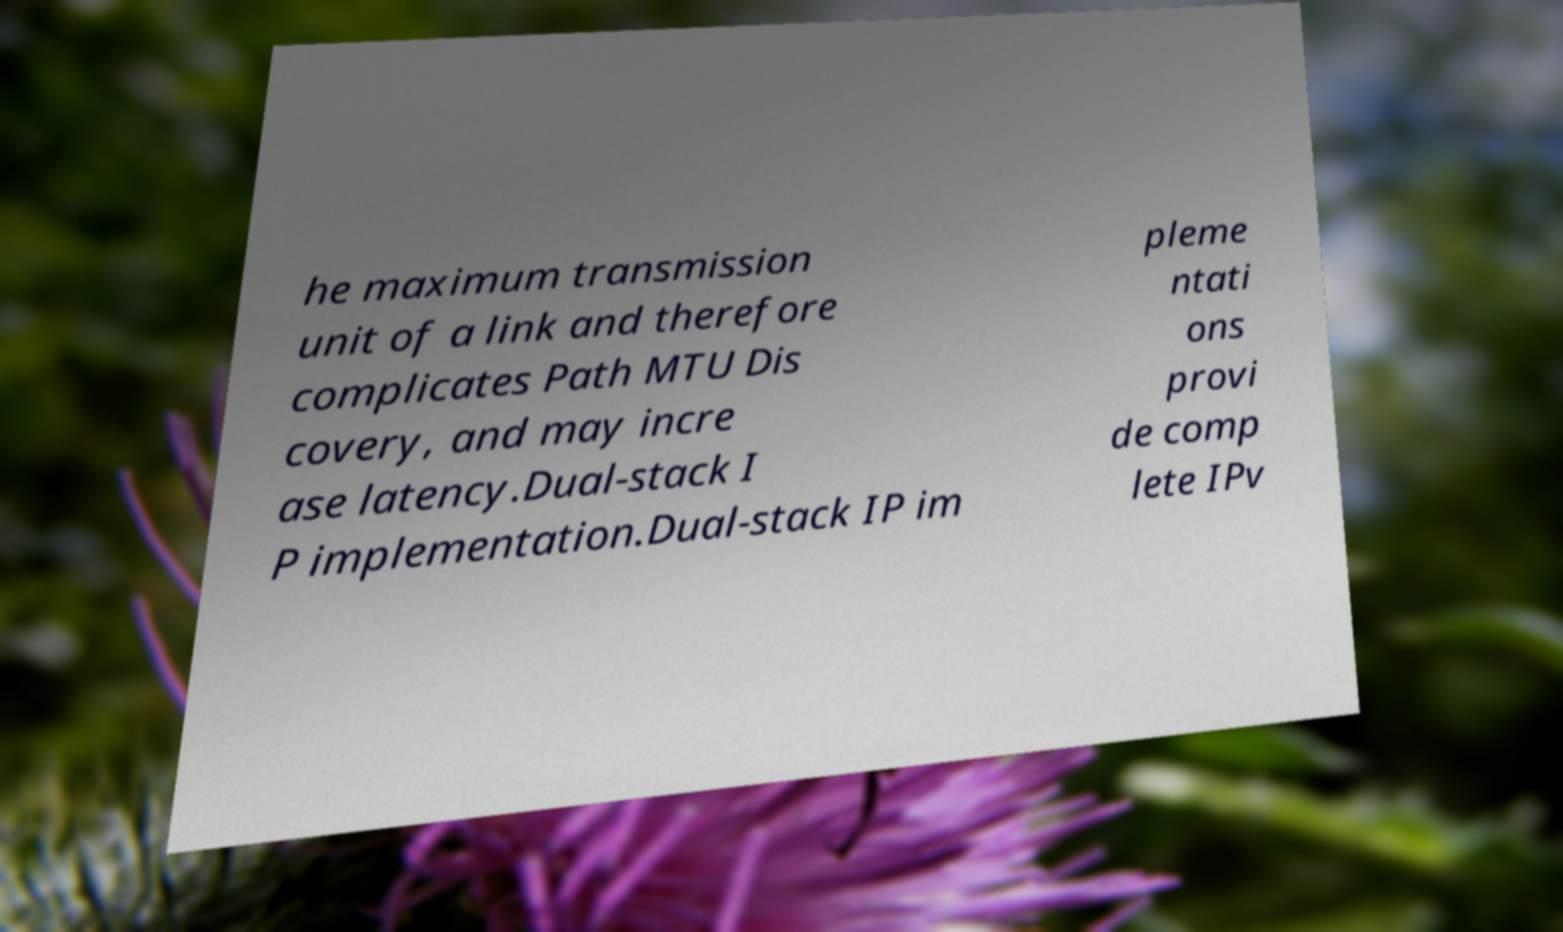Could you assist in decoding the text presented in this image and type it out clearly? he maximum transmission unit of a link and therefore complicates Path MTU Dis covery, and may incre ase latency.Dual-stack I P implementation.Dual-stack IP im pleme ntati ons provi de comp lete IPv 